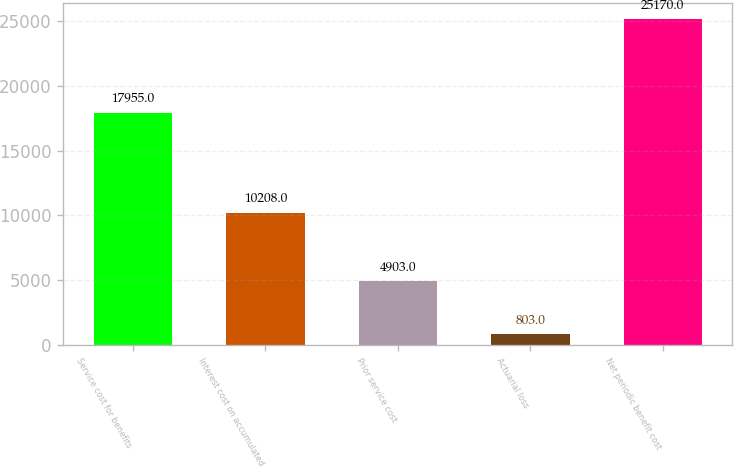Convert chart to OTSL. <chart><loc_0><loc_0><loc_500><loc_500><bar_chart><fcel>Service cost for benefits<fcel>Interest cost on accumulated<fcel>Prior service cost<fcel>Actuarial loss<fcel>Net periodic benefit cost<nl><fcel>17955<fcel>10208<fcel>4903<fcel>803<fcel>25170<nl></chart> 